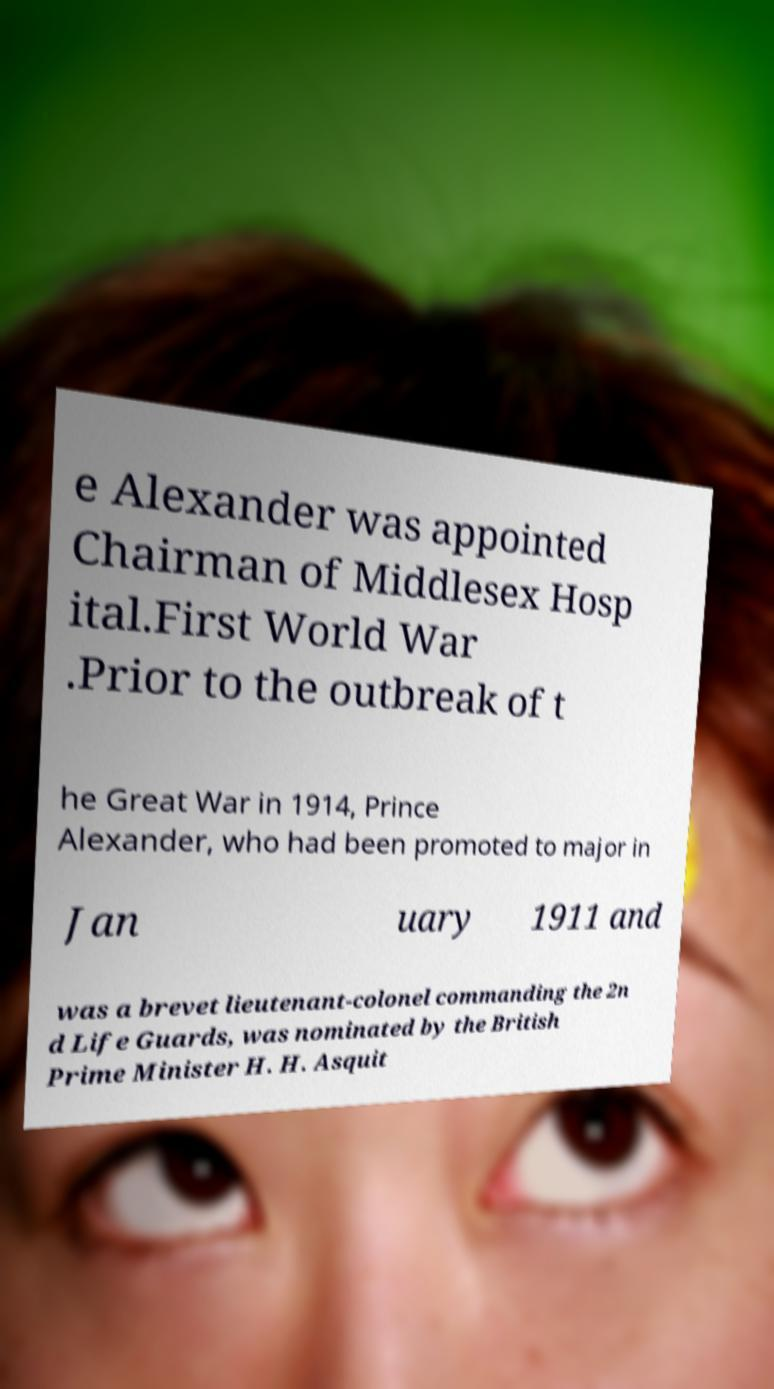Could you assist in decoding the text presented in this image and type it out clearly? e Alexander was appointed Chairman of Middlesex Hosp ital.First World War .Prior to the outbreak of t he Great War in 1914, Prince Alexander, who had been promoted to major in Jan uary 1911 and was a brevet lieutenant-colonel commanding the 2n d Life Guards, was nominated by the British Prime Minister H. H. Asquit 